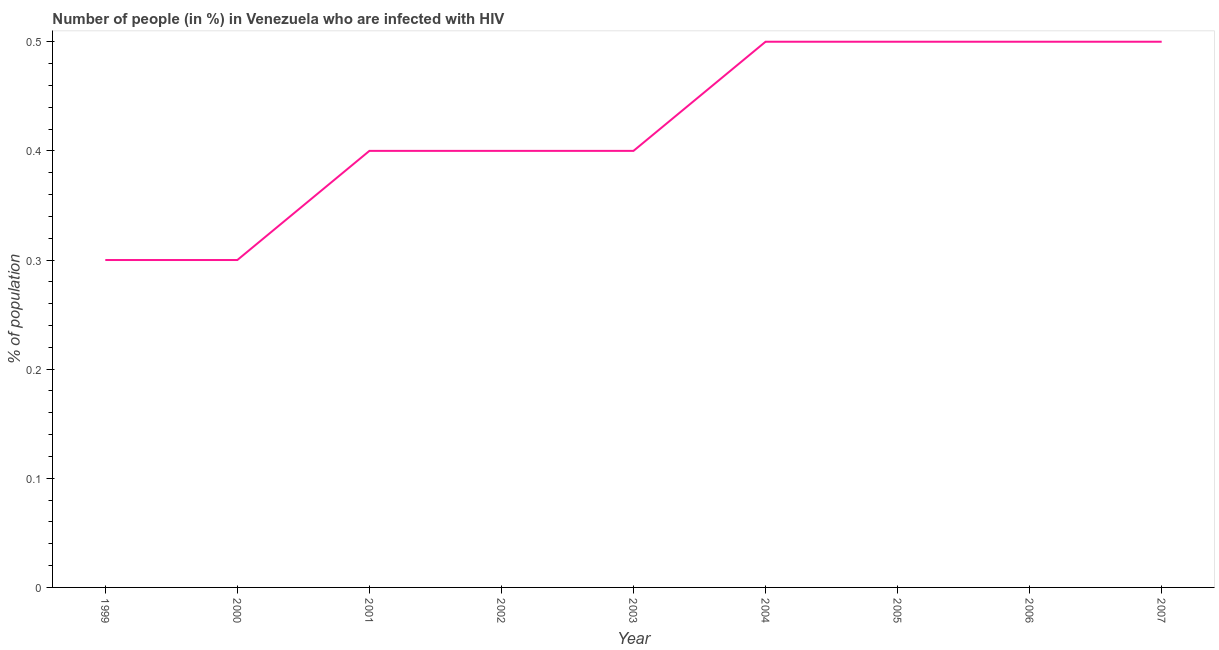Across all years, what is the maximum number of people infected with hiv?
Your response must be concise. 0.5. What is the difference between the number of people infected with hiv in 2002 and 2007?
Your answer should be very brief. -0.1. What is the average number of people infected with hiv per year?
Your response must be concise. 0.42. What is the median number of people infected with hiv?
Your answer should be compact. 0.4. What is the ratio of the number of people infected with hiv in 2001 to that in 2006?
Your answer should be compact. 0.8. Is the number of people infected with hiv in 1999 less than that in 2004?
Your response must be concise. Yes. Is the difference between the number of people infected with hiv in 2002 and 2005 greater than the difference between any two years?
Provide a succinct answer. No. What is the difference between the highest and the second highest number of people infected with hiv?
Keep it short and to the point. 0. Is the sum of the number of people infected with hiv in 2005 and 2007 greater than the maximum number of people infected with hiv across all years?
Offer a very short reply. Yes. What is the difference between the highest and the lowest number of people infected with hiv?
Your answer should be very brief. 0.2. In how many years, is the number of people infected with hiv greater than the average number of people infected with hiv taken over all years?
Keep it short and to the point. 4. What is the difference between two consecutive major ticks on the Y-axis?
Your answer should be compact. 0.1. Are the values on the major ticks of Y-axis written in scientific E-notation?
Your answer should be compact. No. Does the graph contain grids?
Your answer should be very brief. No. What is the title of the graph?
Your answer should be very brief. Number of people (in %) in Venezuela who are infected with HIV. What is the label or title of the Y-axis?
Your answer should be compact. % of population. What is the % of population of 2001?
Offer a very short reply. 0.4. What is the % of population in 2002?
Keep it short and to the point. 0.4. What is the % of population in 2003?
Provide a short and direct response. 0.4. What is the % of population of 2004?
Your answer should be compact. 0.5. What is the % of population in 2006?
Keep it short and to the point. 0.5. What is the difference between the % of population in 1999 and 2001?
Make the answer very short. -0.1. What is the difference between the % of population in 1999 and 2005?
Your response must be concise. -0.2. What is the difference between the % of population in 1999 and 2006?
Provide a short and direct response. -0.2. What is the difference between the % of population in 2000 and 2002?
Provide a succinct answer. -0.1. What is the difference between the % of population in 2000 and 2004?
Make the answer very short. -0.2. What is the difference between the % of population in 2000 and 2007?
Provide a succinct answer. -0.2. What is the difference between the % of population in 2001 and 2003?
Offer a very short reply. 0. What is the difference between the % of population in 2001 and 2004?
Provide a succinct answer. -0.1. What is the difference between the % of population in 2001 and 2006?
Keep it short and to the point. -0.1. What is the difference between the % of population in 2001 and 2007?
Offer a terse response. -0.1. What is the difference between the % of population in 2002 and 2006?
Offer a terse response. -0.1. What is the difference between the % of population in 2002 and 2007?
Offer a very short reply. -0.1. What is the difference between the % of population in 2003 and 2004?
Make the answer very short. -0.1. What is the difference between the % of population in 2003 and 2007?
Provide a succinct answer. -0.1. What is the difference between the % of population in 2004 and 2006?
Your response must be concise. 0. What is the difference between the % of population in 2005 and 2007?
Your response must be concise. 0. What is the ratio of the % of population in 1999 to that in 2000?
Make the answer very short. 1. What is the ratio of the % of population in 1999 to that in 2002?
Offer a terse response. 0.75. What is the ratio of the % of population in 1999 to that in 2003?
Provide a short and direct response. 0.75. What is the ratio of the % of population in 1999 to that in 2004?
Make the answer very short. 0.6. What is the ratio of the % of population in 1999 to that in 2005?
Your answer should be very brief. 0.6. What is the ratio of the % of population in 2000 to that in 2007?
Provide a succinct answer. 0.6. What is the ratio of the % of population in 2001 to that in 2003?
Your answer should be very brief. 1. What is the ratio of the % of population in 2001 to that in 2004?
Offer a very short reply. 0.8. What is the ratio of the % of population in 2001 to that in 2005?
Provide a short and direct response. 0.8. What is the ratio of the % of population in 2001 to that in 2006?
Offer a terse response. 0.8. What is the ratio of the % of population in 2002 to that in 2003?
Provide a short and direct response. 1. What is the ratio of the % of population in 2002 to that in 2004?
Ensure brevity in your answer.  0.8. What is the ratio of the % of population in 2002 to that in 2005?
Your response must be concise. 0.8. What is the ratio of the % of population in 2002 to that in 2006?
Your answer should be compact. 0.8. What is the ratio of the % of population in 2003 to that in 2005?
Offer a terse response. 0.8. What is the ratio of the % of population in 2003 to that in 2007?
Ensure brevity in your answer.  0.8. What is the ratio of the % of population in 2005 to that in 2007?
Your answer should be very brief. 1. What is the ratio of the % of population in 2006 to that in 2007?
Make the answer very short. 1. 